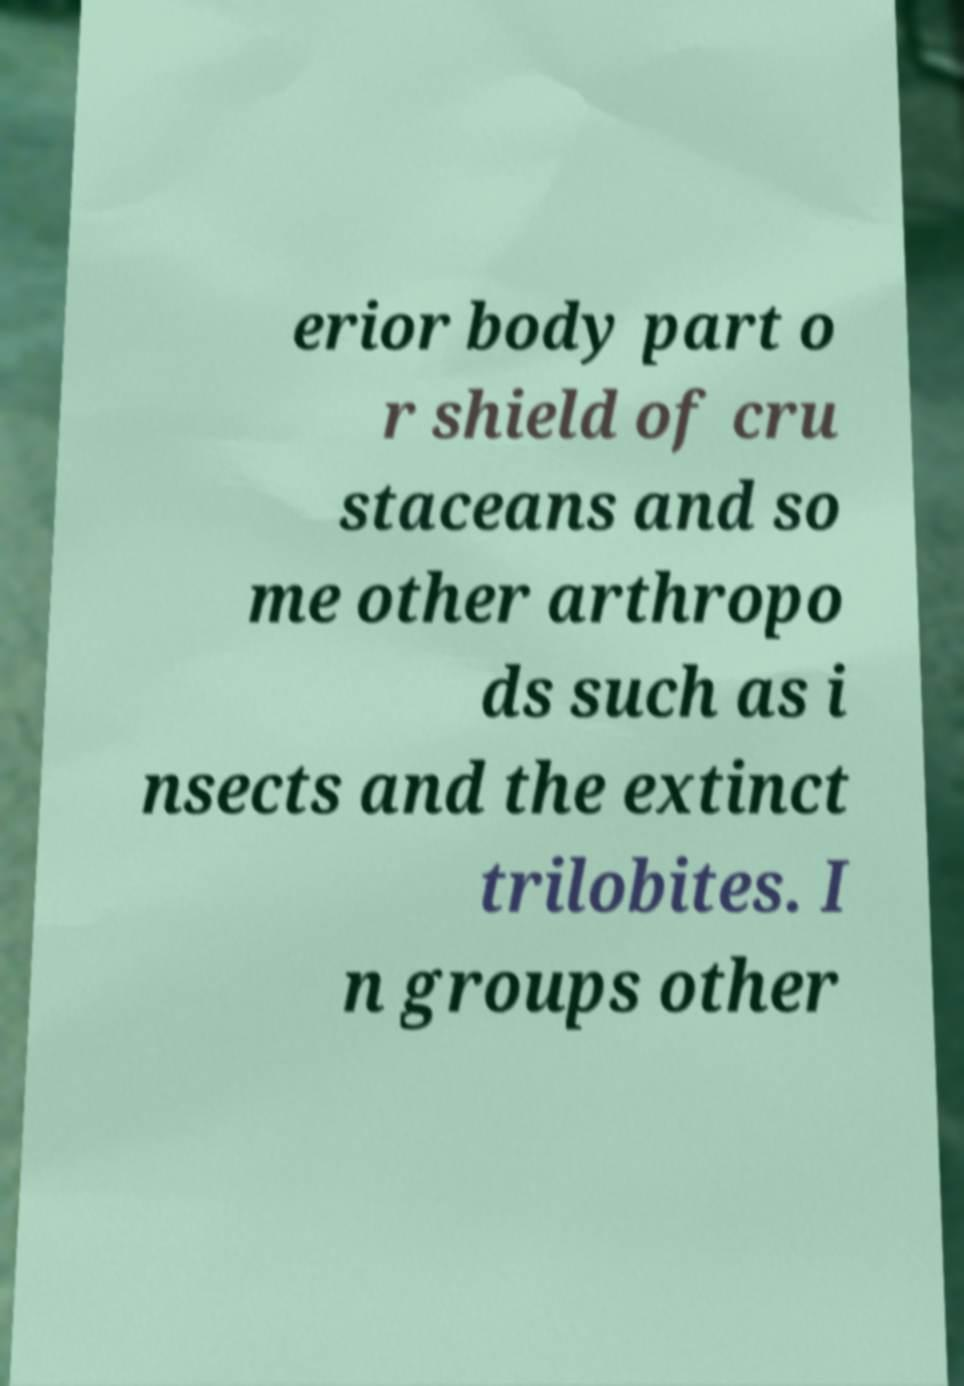What messages or text are displayed in this image? I need them in a readable, typed format. erior body part o r shield of cru staceans and so me other arthropo ds such as i nsects and the extinct trilobites. I n groups other 